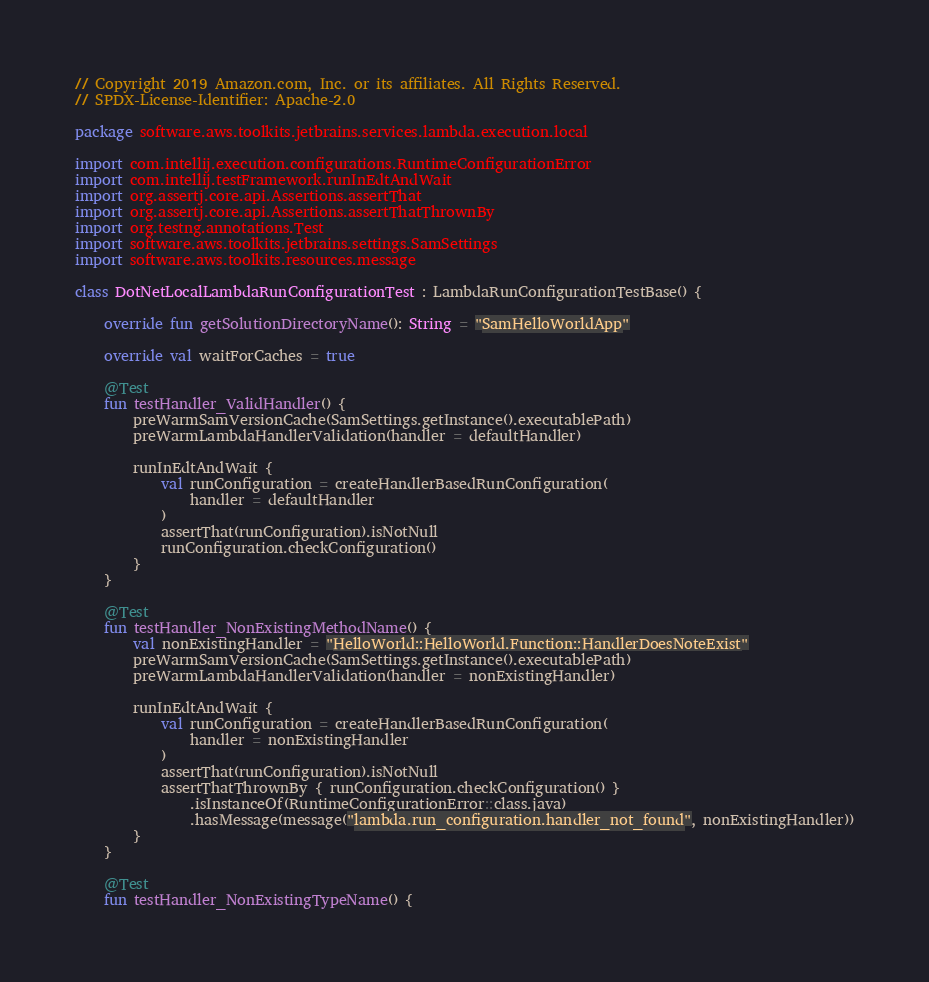<code> <loc_0><loc_0><loc_500><loc_500><_Kotlin_>// Copyright 2019 Amazon.com, Inc. or its affiliates. All Rights Reserved.
// SPDX-License-Identifier: Apache-2.0

package software.aws.toolkits.jetbrains.services.lambda.execution.local

import com.intellij.execution.configurations.RuntimeConfigurationError
import com.intellij.testFramework.runInEdtAndWait
import org.assertj.core.api.Assertions.assertThat
import org.assertj.core.api.Assertions.assertThatThrownBy
import org.testng.annotations.Test
import software.aws.toolkits.jetbrains.settings.SamSettings
import software.aws.toolkits.resources.message

class DotNetLocalLambdaRunConfigurationTest : LambdaRunConfigurationTestBase() {

    override fun getSolutionDirectoryName(): String = "SamHelloWorldApp"

    override val waitForCaches = true

    @Test
    fun testHandler_ValidHandler() {
        preWarmSamVersionCache(SamSettings.getInstance().executablePath)
        preWarmLambdaHandlerValidation(handler = defaultHandler)

        runInEdtAndWait {
            val runConfiguration = createHandlerBasedRunConfiguration(
                handler = defaultHandler
            )
            assertThat(runConfiguration).isNotNull
            runConfiguration.checkConfiguration()
        }
    }

    @Test
    fun testHandler_NonExistingMethodName() {
        val nonExistingHandler = "HelloWorld::HelloWorld.Function::HandlerDoesNoteExist"
        preWarmSamVersionCache(SamSettings.getInstance().executablePath)
        preWarmLambdaHandlerValidation(handler = nonExistingHandler)

        runInEdtAndWait {
            val runConfiguration = createHandlerBasedRunConfiguration(
                handler = nonExistingHandler
            )
            assertThat(runConfiguration).isNotNull
            assertThatThrownBy { runConfiguration.checkConfiguration() }
                .isInstanceOf(RuntimeConfigurationError::class.java)
                .hasMessage(message("lambda.run_configuration.handler_not_found", nonExistingHandler))
        }
    }

    @Test
    fun testHandler_NonExistingTypeName() {</code> 